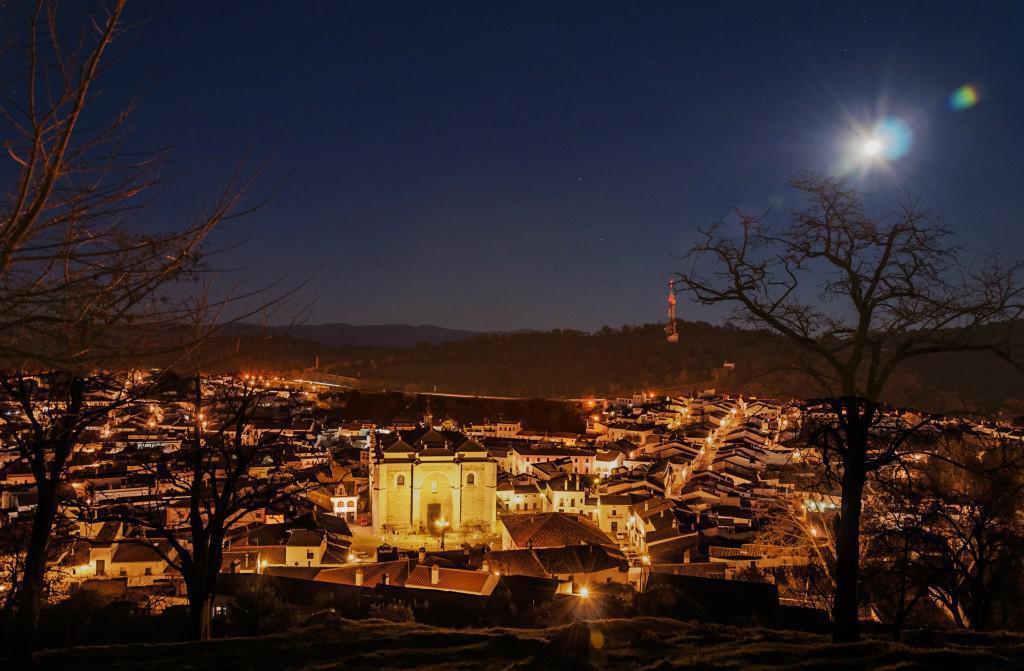In one or two sentences, can you explain what this image depicts? In this picture we can see there are trees. Behind the trees there are buildings, poles with lights, hills and a sky. 